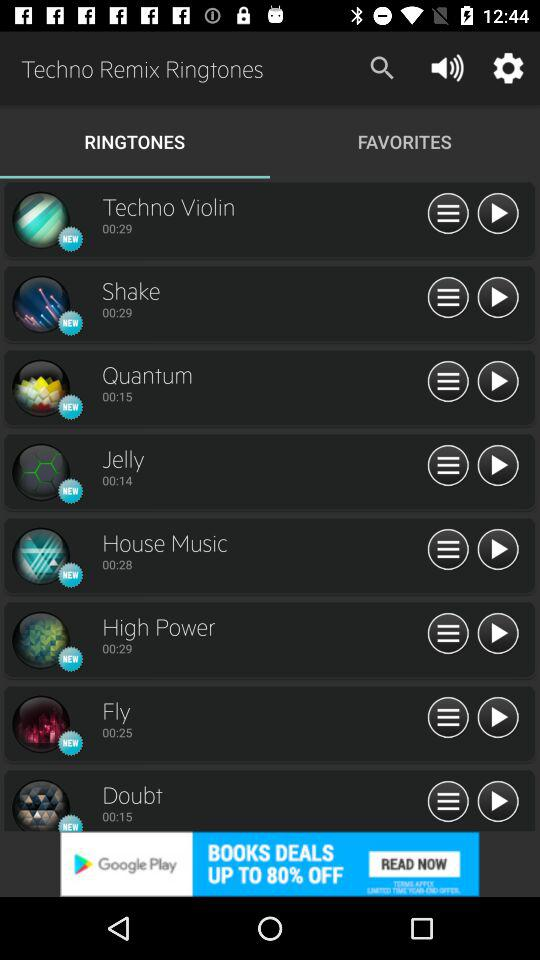What is the duration of the ringtone "Techno Violin"? The duration of the ringtone is 29 seconds. 